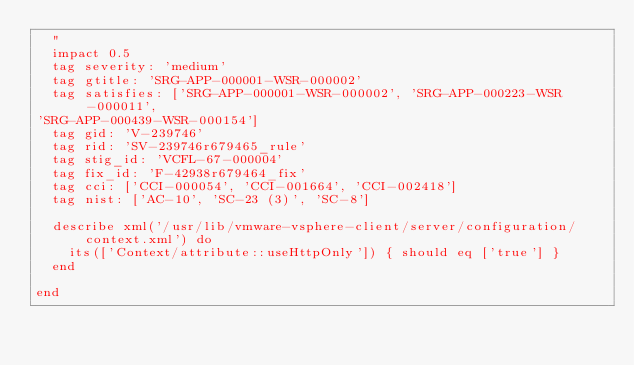Convert code to text. <code><loc_0><loc_0><loc_500><loc_500><_Ruby_>  "
  impact 0.5
  tag severity: 'medium'
  tag gtitle: 'SRG-APP-000001-WSR-000002'
  tag satisfies: ['SRG-APP-000001-WSR-000002', 'SRG-APP-000223-WSR-000011',
'SRG-APP-000439-WSR-000154']
  tag gid: 'V-239746'
  tag rid: 'SV-239746r679465_rule'
  tag stig_id: 'VCFL-67-000004'
  tag fix_id: 'F-42938r679464_fix'
  tag cci: ['CCI-000054', 'CCI-001664', 'CCI-002418']
  tag nist: ['AC-10', 'SC-23 (3)', 'SC-8']

  describe xml('/usr/lib/vmware-vsphere-client/server/configuration/context.xml') do
    its(['Context/attribute::useHttpOnly']) { should eq ['true'] }
  end

end</code> 